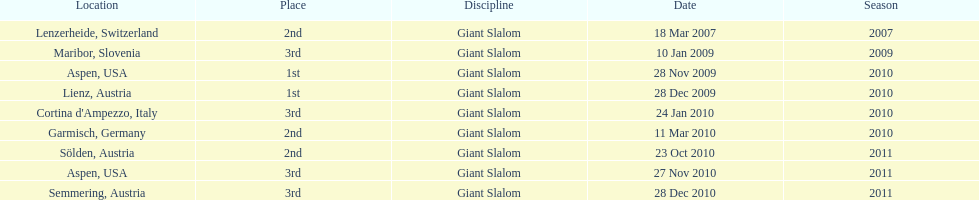The final race finishing place was not 1st but what other place? 3rd. 